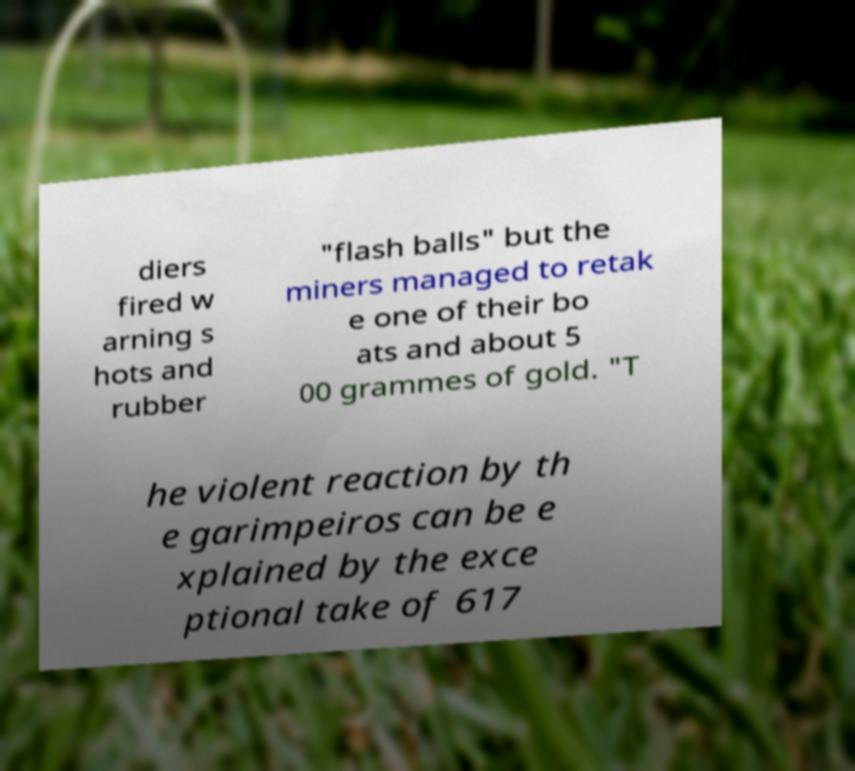What messages or text are displayed in this image? I need them in a readable, typed format. diers fired w arning s hots and rubber "flash balls" but the miners managed to retak e one of their bo ats and about 5 00 grammes of gold. "T he violent reaction by th e garimpeiros can be e xplained by the exce ptional take of 617 